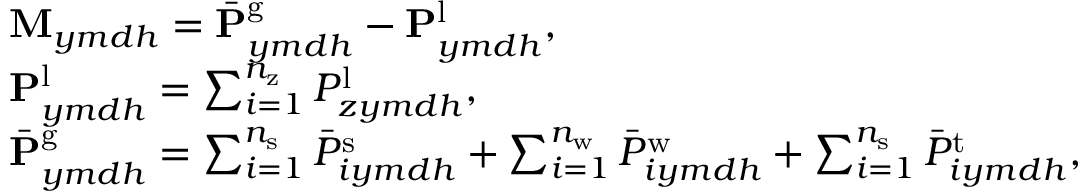<formula> <loc_0><loc_0><loc_500><loc_500>\begin{array} { r l } & { M _ { y m d h } = \bar { P } _ { y m d h } ^ { g } - { P } _ { y m d h } ^ { l } , } \\ & { P _ { y m d h } ^ { l } = \sum _ { i = 1 } ^ { n _ { z } } { P } _ { z y m d h } ^ { l } , } \\ & { \bar { P } _ { y m d h } ^ { g } = \sum _ { i = 1 } ^ { n _ { s } } \bar { P } _ { i y m d h } ^ { s } + \sum _ { i = 1 } ^ { n _ { w } } \bar { P } _ { i y m d h } ^ { w } + \sum _ { i = 1 } ^ { n _ { s } } \bar { P } _ { i y m d h } ^ { t } , } \end{array}</formula> 